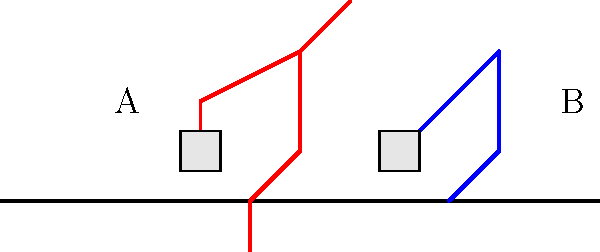When lifting heavy objects, which stick figure (A or B) demonstrates the proper biomechanical technique to reduce the risk of back injury? To understand the proper biomechanical technique for lifting heavy objects safely, let's analyze both stick figures:

1. Figure A (red):
   - Bent knees and hips, keeping the back straight
   - Arms close to the body
   - Lifting with leg muscles

2. Figure B (blue):
   - Bent back, straight legs
   - Arms extended away from the body
   - Lifting primarily with back muscles

The proper technique is demonstrated by Figure A because:

1. Bending the knees and hips while keeping the back straight distributes the load more evenly across the body's stronger muscle groups (legs and core).

2. Keeping the arms close to the body reduces the moment arm, which decreases the torque on the spine.

3. Using leg muscles (quadriceps and glutes) to lift provides more power and stability compared to relying on back muscles alone.

4. This position maintains the natural curve of the spine, reducing the risk of disc herniation or other back injuries.

5. The center of gravity is kept closer to the body, improving balance and control during the lift.

In contrast, Figure B demonstrates poor technique that increases the risk of injury by:

1. Placing excessive strain on the lower back muscles and spinal discs
2. Creating a longer moment arm, increasing torque on the spine
3. Relying primarily on weaker back muscles instead of stronger leg muscles
4. Potentially causing loss of balance due to the shifted center of gravity

By adopting the technique shown in Figure A, you can significantly reduce the risk of back injury when lifting heavy objects.
Answer: Figure A 